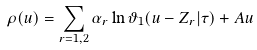Convert formula to latex. <formula><loc_0><loc_0><loc_500><loc_500>\rho ( u ) = \sum _ { r = 1 , 2 } \alpha _ { r } \ln \vartheta _ { 1 } ( u - Z _ { r } | \tau ) + A u</formula> 